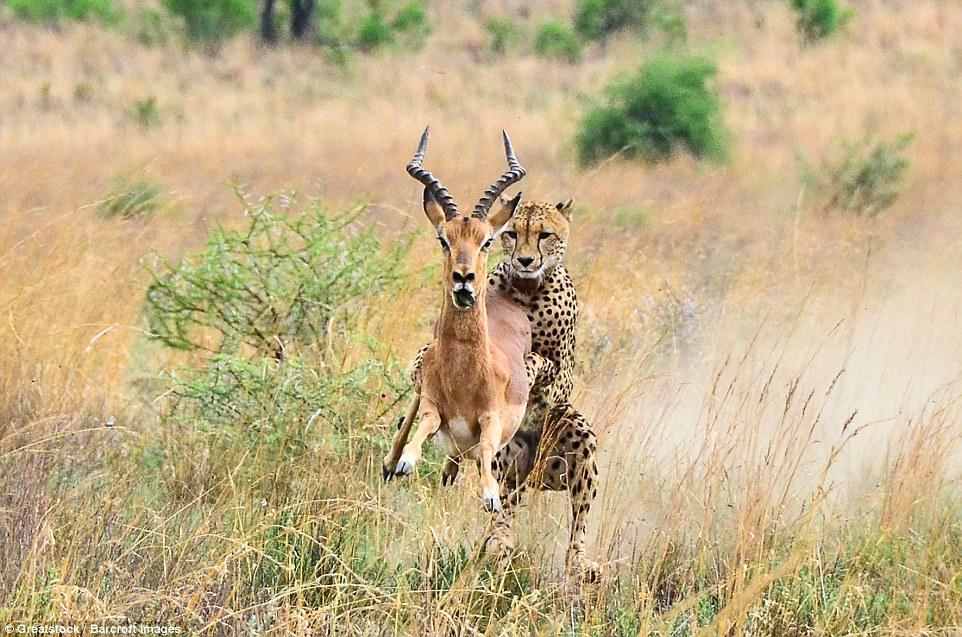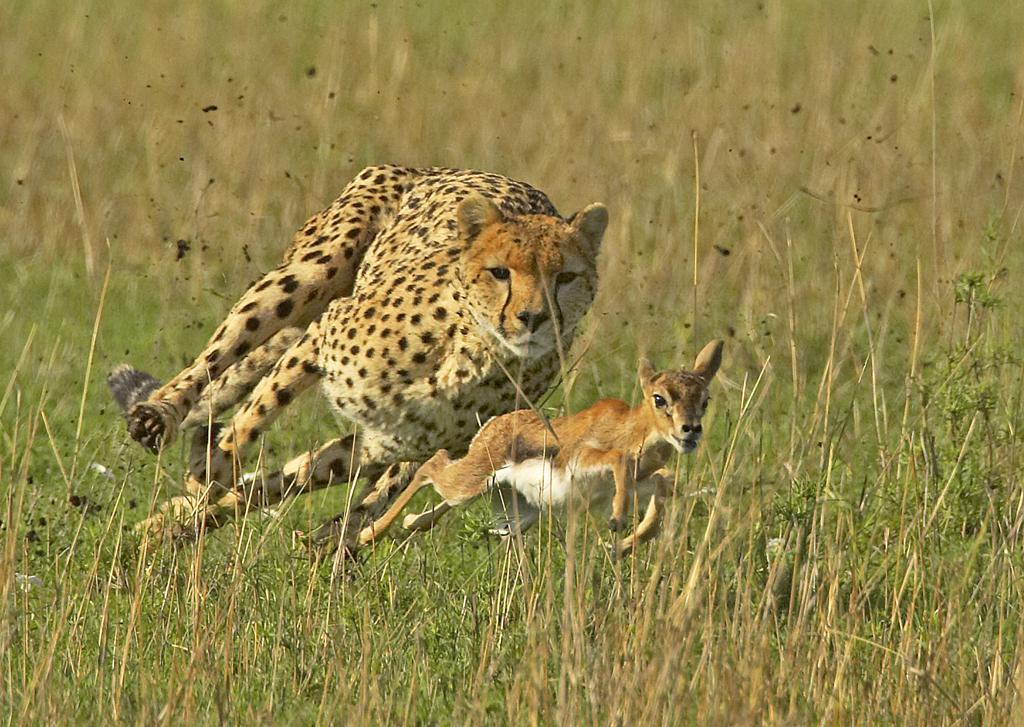The first image is the image on the left, the second image is the image on the right. Assess this claim about the two images: "One image includes more than one spotted cat on the ground.". Correct or not? Answer yes or no. No. The first image is the image on the left, the second image is the image on the right. Considering the images on both sides, is "There are exactly two animals in the image on the left." valid? Answer yes or no. Yes. 